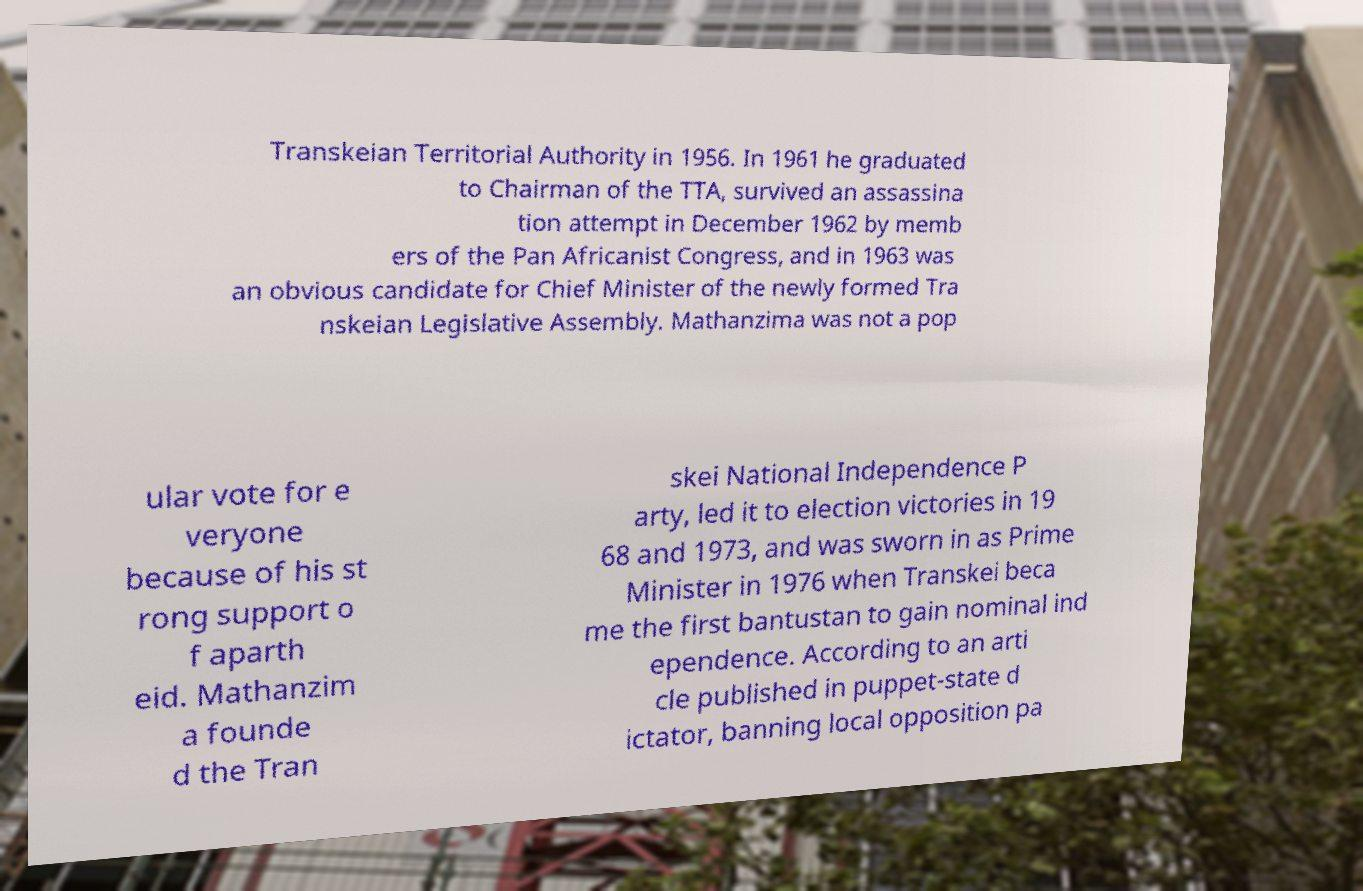For documentation purposes, I need the text within this image transcribed. Could you provide that? Transkeian Territorial Authority in 1956. In 1961 he graduated to Chairman of the TTA, survived an assassina tion attempt in December 1962 by memb ers of the Pan Africanist Congress, and in 1963 was an obvious candidate for Chief Minister of the newly formed Tra nskeian Legislative Assembly. Mathanzima was not a pop ular vote for e veryone because of his st rong support o f aparth eid. Mathanzim a founde d the Tran skei National Independence P arty, led it to election victories in 19 68 and 1973, and was sworn in as Prime Minister in 1976 when Transkei beca me the first bantustan to gain nominal ind ependence. According to an arti cle published in puppet-state d ictator, banning local opposition pa 